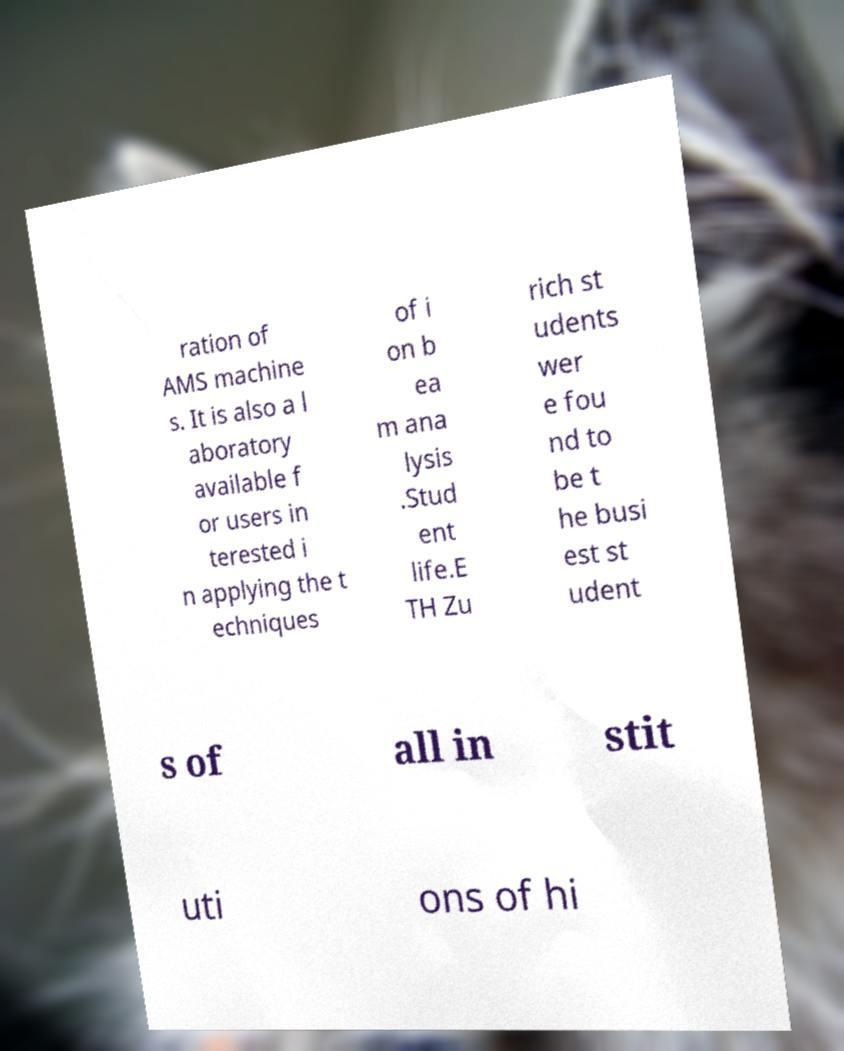There's text embedded in this image that I need extracted. Can you transcribe it verbatim? ration of AMS machine s. It is also a l aboratory available f or users in terested i n applying the t echniques of i on b ea m ana lysis .Stud ent life.E TH Zu rich st udents wer e fou nd to be t he busi est st udent s of all in stit uti ons of hi 